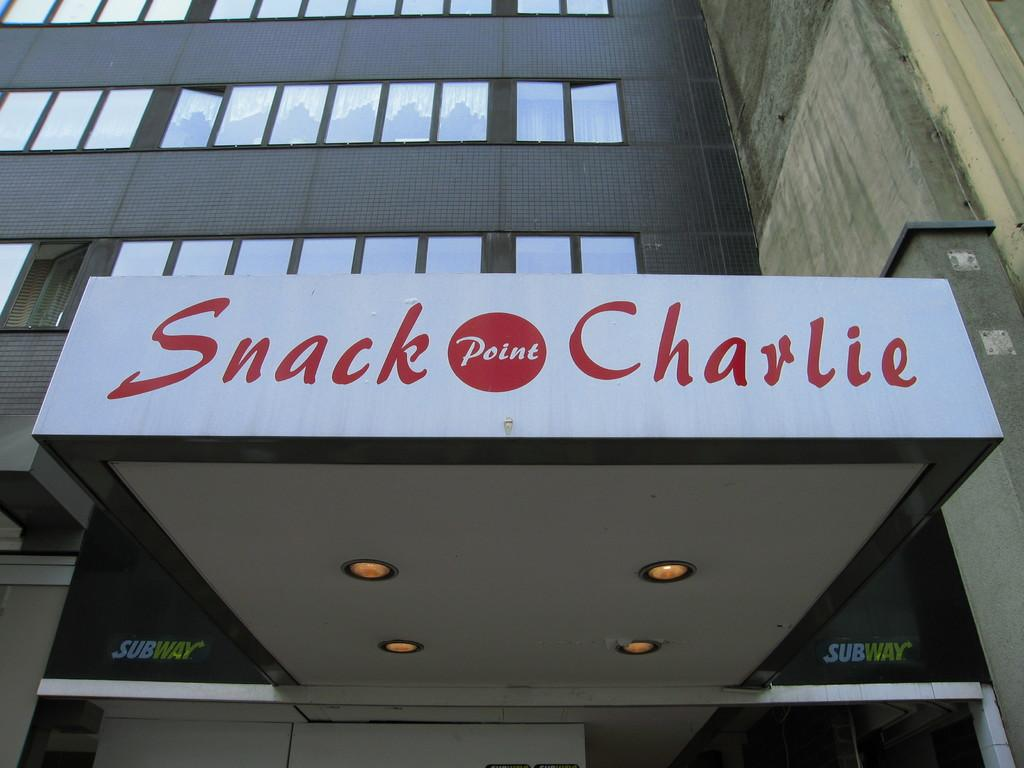What is written or displayed on the building in the image? There are letters on a building in the image. What type of material is used for the windows in the image? There are glass windows in the image. What can be seen illuminated in the image? There are lights visible in the image. How many fingers are visible on the building in the image? There are no fingers visible on the building in the image. What type of linen is draped over the windows in the image? There is no linen present in the image; the windows are made of glass. 